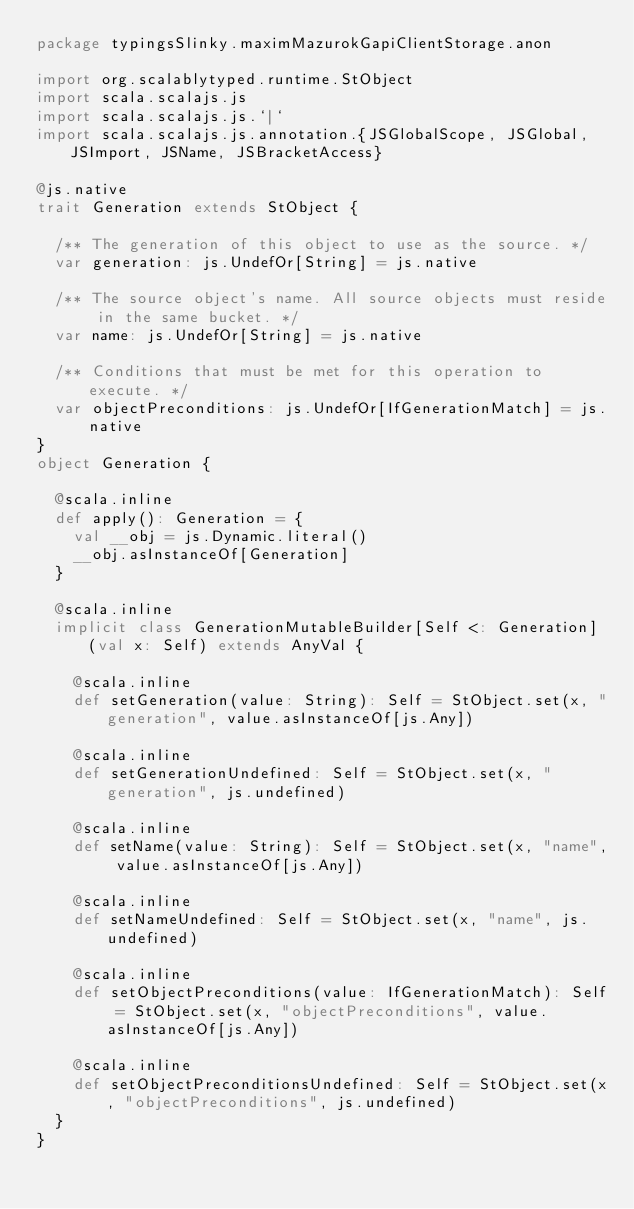<code> <loc_0><loc_0><loc_500><loc_500><_Scala_>package typingsSlinky.maximMazurokGapiClientStorage.anon

import org.scalablytyped.runtime.StObject
import scala.scalajs.js
import scala.scalajs.js.`|`
import scala.scalajs.js.annotation.{JSGlobalScope, JSGlobal, JSImport, JSName, JSBracketAccess}

@js.native
trait Generation extends StObject {
  
  /** The generation of this object to use as the source. */
  var generation: js.UndefOr[String] = js.native
  
  /** The source object's name. All source objects must reside in the same bucket. */
  var name: js.UndefOr[String] = js.native
  
  /** Conditions that must be met for this operation to execute. */
  var objectPreconditions: js.UndefOr[IfGenerationMatch] = js.native
}
object Generation {
  
  @scala.inline
  def apply(): Generation = {
    val __obj = js.Dynamic.literal()
    __obj.asInstanceOf[Generation]
  }
  
  @scala.inline
  implicit class GenerationMutableBuilder[Self <: Generation] (val x: Self) extends AnyVal {
    
    @scala.inline
    def setGeneration(value: String): Self = StObject.set(x, "generation", value.asInstanceOf[js.Any])
    
    @scala.inline
    def setGenerationUndefined: Self = StObject.set(x, "generation", js.undefined)
    
    @scala.inline
    def setName(value: String): Self = StObject.set(x, "name", value.asInstanceOf[js.Any])
    
    @scala.inline
    def setNameUndefined: Self = StObject.set(x, "name", js.undefined)
    
    @scala.inline
    def setObjectPreconditions(value: IfGenerationMatch): Self = StObject.set(x, "objectPreconditions", value.asInstanceOf[js.Any])
    
    @scala.inline
    def setObjectPreconditionsUndefined: Self = StObject.set(x, "objectPreconditions", js.undefined)
  }
}
</code> 